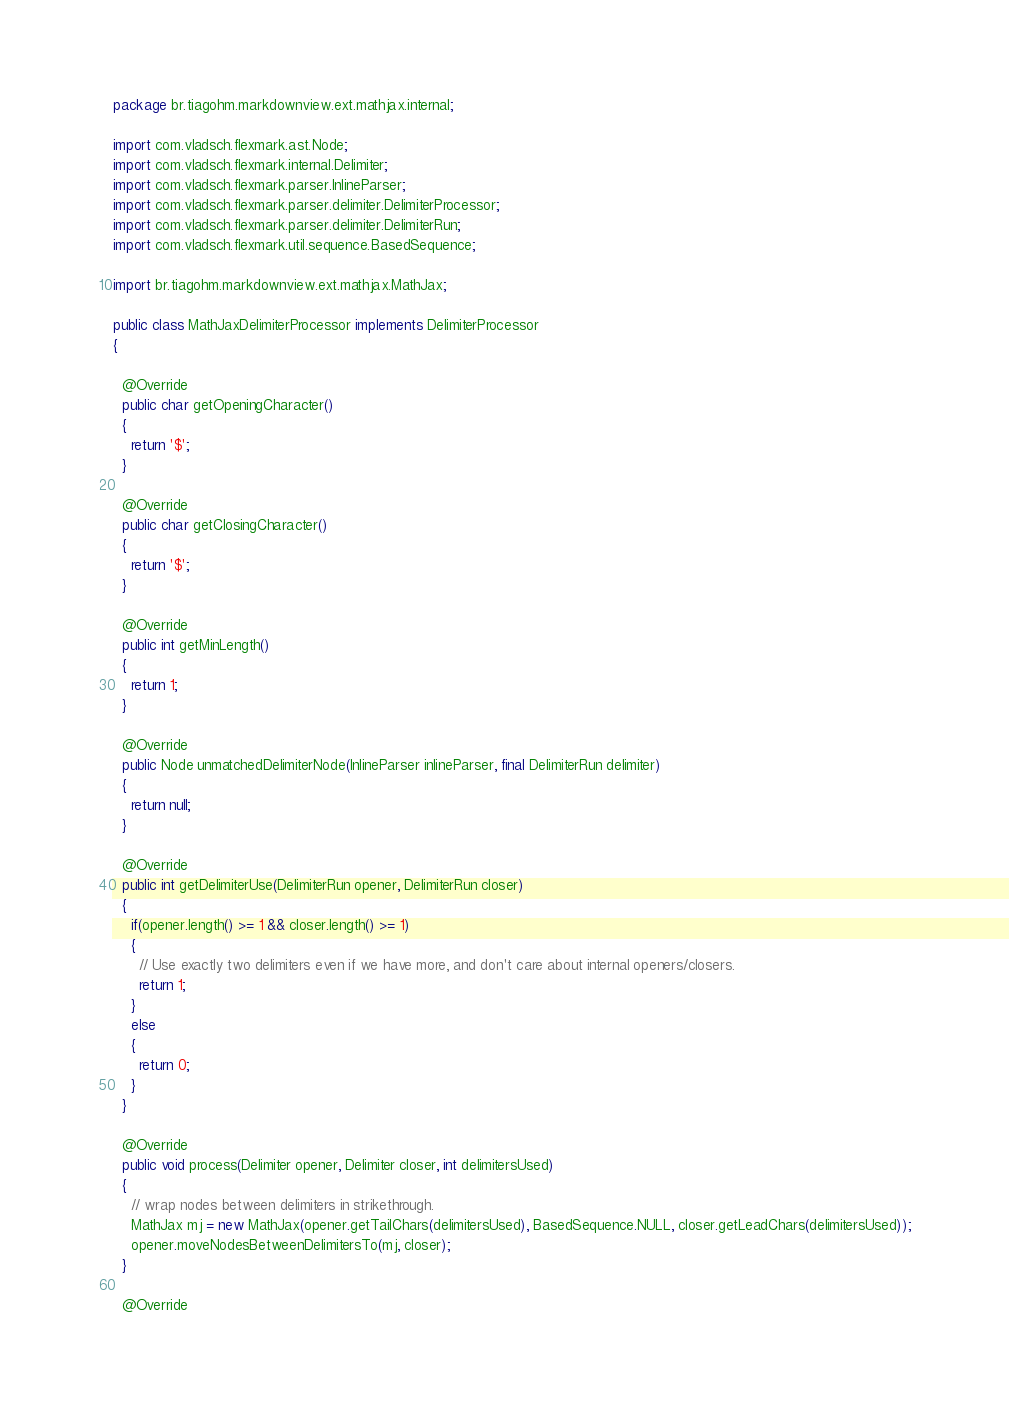<code> <loc_0><loc_0><loc_500><loc_500><_Java_>package br.tiagohm.markdownview.ext.mathjax.internal;

import com.vladsch.flexmark.ast.Node;
import com.vladsch.flexmark.internal.Delimiter;
import com.vladsch.flexmark.parser.InlineParser;
import com.vladsch.flexmark.parser.delimiter.DelimiterProcessor;
import com.vladsch.flexmark.parser.delimiter.DelimiterRun;
import com.vladsch.flexmark.util.sequence.BasedSequence;

import br.tiagohm.markdownview.ext.mathjax.MathJax;

public class MathJaxDelimiterProcessor implements DelimiterProcessor
{

  @Override
  public char getOpeningCharacter()
  {
    return '$';
  }

  @Override
  public char getClosingCharacter()
  {
    return '$';
  }

  @Override
  public int getMinLength()
  {
    return 1;
  }

  @Override
  public Node unmatchedDelimiterNode(InlineParser inlineParser, final DelimiterRun delimiter)
  {
    return null;
  }

  @Override
  public int getDelimiterUse(DelimiterRun opener, DelimiterRun closer)
  {
    if(opener.length() >= 1 && closer.length() >= 1)
    {
      // Use exactly two delimiters even if we have more, and don't care about internal openers/closers.
      return 1;
    }
    else
    {
      return 0;
    }
  }

  @Override
  public void process(Delimiter opener, Delimiter closer, int delimitersUsed)
  {
    // wrap nodes between delimiters in strikethrough.
    MathJax mj = new MathJax(opener.getTailChars(delimitersUsed), BasedSequence.NULL, closer.getLeadChars(delimitersUsed));
    opener.moveNodesBetweenDelimitersTo(mj, closer);
  }

  @Override</code> 